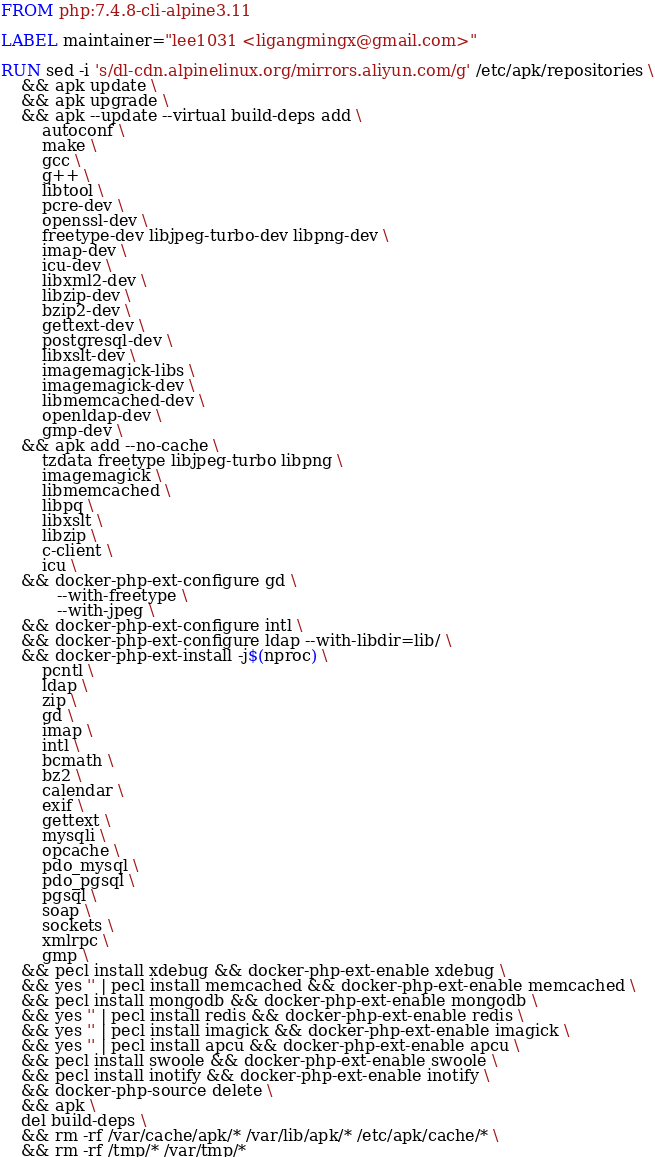Convert code to text. <code><loc_0><loc_0><loc_500><loc_500><_Dockerfile_>FROM php:7.4.8-cli-alpine3.11

LABEL maintainer="lee1031 <ligangmingx@gmail.com>"

RUN sed -i 's/dl-cdn.alpinelinux.org/mirrors.aliyun.com/g' /etc/apk/repositories \
    && apk update \
    && apk upgrade \
    && apk --update --virtual build-deps add \
        autoconf \
        make \
        gcc \
        g++ \
        libtool \
        pcre-dev \
        openssl-dev \
        freetype-dev libjpeg-turbo-dev libpng-dev \
        imap-dev \
        icu-dev \
        libxml2-dev \
        libzip-dev \
        bzip2-dev \
        gettext-dev \
        postgresql-dev \
        libxslt-dev \
        imagemagick-libs \
        imagemagick-dev \
        libmemcached-dev \
        openldap-dev \
        gmp-dev \
    && apk add --no-cache \
        tzdata freetype libjpeg-turbo libpng \
        imagemagick \
        libmemcached \
        libpq \
        libxslt \
        libzip \
        c-client \
        icu \
    && docker-php-ext-configure gd \
           --with-freetype \
           --with-jpeg \
    && docker-php-ext-configure intl \
    && docker-php-ext-configure ldap --with-libdir=lib/ \
    && docker-php-ext-install -j$(nproc) \
        pcntl \
        ldap \
        zip \
        gd \
        imap \
        intl \
        bcmath \
        bz2 \
        calendar \
        exif \
        gettext \
        mysqli \
        opcache \
        pdo_mysql \
        pdo_pgsql \
        pgsql \
        soap \
        sockets \
        xmlrpc \
        gmp \
    && pecl install xdebug && docker-php-ext-enable xdebug \
    && yes '' | pecl install memcached && docker-php-ext-enable memcached \
    && pecl install mongodb && docker-php-ext-enable mongodb \
    && yes '' | pecl install redis && docker-php-ext-enable redis \
    && yes '' | pecl install imagick && docker-php-ext-enable imagick \
    && yes '' | pecl install apcu && docker-php-ext-enable apcu \
    && pecl install swoole && docker-php-ext-enable swoole \
    && pecl install inotify && docker-php-ext-enable inotify \
    && docker-php-source delete \
    && apk \
    del build-deps \
    && rm -rf /var/cache/apk/* /var/lib/apk/* /etc/apk/cache/* \
    && rm -rf /tmp/* /var/tmp/*
</code> 